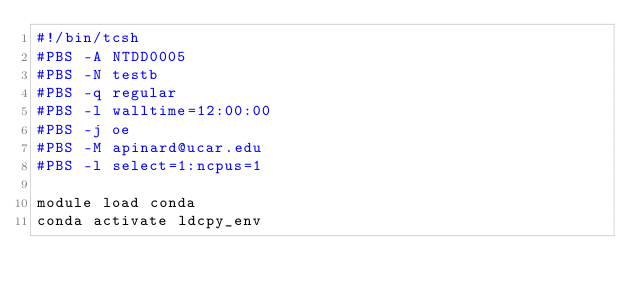<code> <loc_0><loc_0><loc_500><loc_500><_Bash_>#!/bin/tcsh
#PBS -A NTDD0005
#PBS -N testb
#PBS -q regular
#PBS -l walltime=12:00:00
#PBS -j oe
#PBS -M apinard@ucar.edu
#PBS -l select=1:ncpus=1

module load conda
conda activate ldcpy_env
</code> 